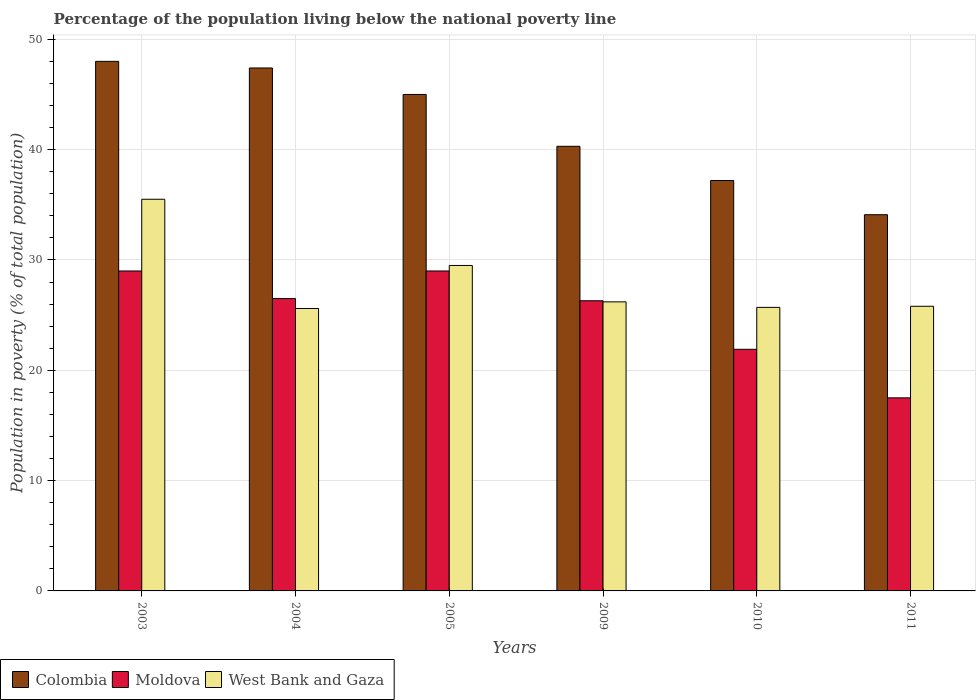How many different coloured bars are there?
Provide a succinct answer. 3. Are the number of bars on each tick of the X-axis equal?
Make the answer very short. Yes. How many bars are there on the 1st tick from the left?
Give a very brief answer. 3. How many bars are there on the 3rd tick from the right?
Provide a succinct answer. 3. What is the label of the 3rd group of bars from the left?
Offer a very short reply. 2005. Across all years, what is the maximum percentage of the population living below the national poverty line in Colombia?
Provide a short and direct response. 48. Across all years, what is the minimum percentage of the population living below the national poverty line in Colombia?
Offer a very short reply. 34.1. What is the total percentage of the population living below the national poverty line in West Bank and Gaza in the graph?
Your answer should be compact. 168.3. What is the difference between the percentage of the population living below the national poverty line in Colombia in 2010 and the percentage of the population living below the national poverty line in West Bank and Gaza in 2004?
Provide a succinct answer. 11.6. What is the average percentage of the population living below the national poverty line in Colombia per year?
Your response must be concise. 42. In the year 2004, what is the difference between the percentage of the population living below the national poverty line in Moldova and percentage of the population living below the national poverty line in West Bank and Gaza?
Your response must be concise. 0.9. What is the ratio of the percentage of the population living below the national poverty line in Moldova in 2005 to that in 2010?
Ensure brevity in your answer.  1.32. Is the percentage of the population living below the national poverty line in Colombia in 2010 less than that in 2011?
Provide a succinct answer. No. Is the difference between the percentage of the population living below the national poverty line in Moldova in 2003 and 2009 greater than the difference between the percentage of the population living below the national poverty line in West Bank and Gaza in 2003 and 2009?
Provide a short and direct response. No. What is the difference between the highest and the second highest percentage of the population living below the national poverty line in Moldova?
Your answer should be very brief. 0. In how many years, is the percentage of the population living below the national poverty line in Moldova greater than the average percentage of the population living below the national poverty line in Moldova taken over all years?
Give a very brief answer. 4. Is the sum of the percentage of the population living below the national poverty line in Colombia in 2004 and 2005 greater than the maximum percentage of the population living below the national poverty line in West Bank and Gaza across all years?
Give a very brief answer. Yes. What does the 2nd bar from the left in 2010 represents?
Your answer should be compact. Moldova. What does the 2nd bar from the right in 2010 represents?
Ensure brevity in your answer.  Moldova. Is it the case that in every year, the sum of the percentage of the population living below the national poverty line in Moldova and percentage of the population living below the national poverty line in West Bank and Gaza is greater than the percentage of the population living below the national poverty line in Colombia?
Ensure brevity in your answer.  Yes. How many bars are there?
Give a very brief answer. 18. Are all the bars in the graph horizontal?
Your response must be concise. No. How many years are there in the graph?
Your response must be concise. 6. Are the values on the major ticks of Y-axis written in scientific E-notation?
Make the answer very short. No. Does the graph contain grids?
Offer a very short reply. Yes. How many legend labels are there?
Offer a very short reply. 3. What is the title of the graph?
Provide a succinct answer. Percentage of the population living below the national poverty line. Does "Congo (Democratic)" appear as one of the legend labels in the graph?
Provide a short and direct response. No. What is the label or title of the X-axis?
Ensure brevity in your answer.  Years. What is the label or title of the Y-axis?
Offer a very short reply. Population in poverty (% of total population). What is the Population in poverty (% of total population) of Moldova in 2003?
Keep it short and to the point. 29. What is the Population in poverty (% of total population) in West Bank and Gaza in 2003?
Ensure brevity in your answer.  35.5. What is the Population in poverty (% of total population) of Colombia in 2004?
Your answer should be very brief. 47.4. What is the Population in poverty (% of total population) of West Bank and Gaza in 2004?
Provide a succinct answer. 25.6. What is the Population in poverty (% of total population) in Moldova in 2005?
Your answer should be very brief. 29. What is the Population in poverty (% of total population) in West Bank and Gaza in 2005?
Provide a succinct answer. 29.5. What is the Population in poverty (% of total population) in Colombia in 2009?
Make the answer very short. 40.3. What is the Population in poverty (% of total population) in Moldova in 2009?
Offer a terse response. 26.3. What is the Population in poverty (% of total population) of West Bank and Gaza in 2009?
Make the answer very short. 26.2. What is the Population in poverty (% of total population) of Colombia in 2010?
Make the answer very short. 37.2. What is the Population in poverty (% of total population) of Moldova in 2010?
Your answer should be compact. 21.9. What is the Population in poverty (% of total population) in West Bank and Gaza in 2010?
Provide a short and direct response. 25.7. What is the Population in poverty (% of total population) in Colombia in 2011?
Your answer should be very brief. 34.1. What is the Population in poverty (% of total population) in West Bank and Gaza in 2011?
Provide a short and direct response. 25.8. Across all years, what is the maximum Population in poverty (% of total population) in West Bank and Gaza?
Offer a very short reply. 35.5. Across all years, what is the minimum Population in poverty (% of total population) in Colombia?
Your answer should be compact. 34.1. Across all years, what is the minimum Population in poverty (% of total population) of West Bank and Gaza?
Make the answer very short. 25.6. What is the total Population in poverty (% of total population) of Colombia in the graph?
Offer a very short reply. 252. What is the total Population in poverty (% of total population) in Moldova in the graph?
Your answer should be compact. 150.2. What is the total Population in poverty (% of total population) of West Bank and Gaza in the graph?
Make the answer very short. 168.3. What is the difference between the Population in poverty (% of total population) in Moldova in 2003 and that in 2004?
Your answer should be very brief. 2.5. What is the difference between the Population in poverty (% of total population) of Colombia in 2003 and that in 2005?
Offer a terse response. 3. What is the difference between the Population in poverty (% of total population) in West Bank and Gaza in 2003 and that in 2005?
Ensure brevity in your answer.  6. What is the difference between the Population in poverty (% of total population) of Colombia in 2003 and that in 2009?
Keep it short and to the point. 7.7. What is the difference between the Population in poverty (% of total population) in Moldova in 2003 and that in 2009?
Provide a succinct answer. 2.7. What is the difference between the Population in poverty (% of total population) in Moldova in 2003 and that in 2010?
Ensure brevity in your answer.  7.1. What is the difference between the Population in poverty (% of total population) in West Bank and Gaza in 2003 and that in 2010?
Your answer should be compact. 9.8. What is the difference between the Population in poverty (% of total population) of Colombia in 2003 and that in 2011?
Your response must be concise. 13.9. What is the difference between the Population in poverty (% of total population) of Moldova in 2004 and that in 2005?
Keep it short and to the point. -2.5. What is the difference between the Population in poverty (% of total population) of West Bank and Gaza in 2004 and that in 2005?
Your response must be concise. -3.9. What is the difference between the Population in poverty (% of total population) in Moldova in 2004 and that in 2009?
Your response must be concise. 0.2. What is the difference between the Population in poverty (% of total population) of Colombia in 2004 and that in 2010?
Offer a terse response. 10.2. What is the difference between the Population in poverty (% of total population) of Moldova in 2004 and that in 2010?
Your response must be concise. 4.6. What is the difference between the Population in poverty (% of total population) of Colombia in 2005 and that in 2009?
Offer a very short reply. 4.7. What is the difference between the Population in poverty (% of total population) of Moldova in 2005 and that in 2009?
Your answer should be compact. 2.7. What is the difference between the Population in poverty (% of total population) in West Bank and Gaza in 2005 and that in 2009?
Your answer should be very brief. 3.3. What is the difference between the Population in poverty (% of total population) of Moldova in 2005 and that in 2011?
Offer a very short reply. 11.5. What is the difference between the Population in poverty (% of total population) in Moldova in 2009 and that in 2010?
Your response must be concise. 4.4. What is the difference between the Population in poverty (% of total population) of West Bank and Gaza in 2009 and that in 2010?
Your answer should be compact. 0.5. What is the difference between the Population in poverty (% of total population) in West Bank and Gaza in 2010 and that in 2011?
Your response must be concise. -0.1. What is the difference between the Population in poverty (% of total population) in Colombia in 2003 and the Population in poverty (% of total population) in Moldova in 2004?
Provide a short and direct response. 21.5. What is the difference between the Population in poverty (% of total population) in Colombia in 2003 and the Population in poverty (% of total population) in West Bank and Gaza in 2004?
Provide a succinct answer. 22.4. What is the difference between the Population in poverty (% of total population) of Colombia in 2003 and the Population in poverty (% of total population) of Moldova in 2009?
Offer a very short reply. 21.7. What is the difference between the Population in poverty (% of total population) of Colombia in 2003 and the Population in poverty (% of total population) of West Bank and Gaza in 2009?
Offer a very short reply. 21.8. What is the difference between the Population in poverty (% of total population) of Moldova in 2003 and the Population in poverty (% of total population) of West Bank and Gaza in 2009?
Offer a very short reply. 2.8. What is the difference between the Population in poverty (% of total population) of Colombia in 2003 and the Population in poverty (% of total population) of Moldova in 2010?
Provide a short and direct response. 26.1. What is the difference between the Population in poverty (% of total population) of Colombia in 2003 and the Population in poverty (% of total population) of West Bank and Gaza in 2010?
Your response must be concise. 22.3. What is the difference between the Population in poverty (% of total population) of Colombia in 2003 and the Population in poverty (% of total population) of Moldova in 2011?
Your response must be concise. 30.5. What is the difference between the Population in poverty (% of total population) of Colombia in 2004 and the Population in poverty (% of total population) of West Bank and Gaza in 2005?
Give a very brief answer. 17.9. What is the difference between the Population in poverty (% of total population) in Moldova in 2004 and the Population in poverty (% of total population) in West Bank and Gaza in 2005?
Offer a very short reply. -3. What is the difference between the Population in poverty (% of total population) of Colombia in 2004 and the Population in poverty (% of total population) of Moldova in 2009?
Give a very brief answer. 21.1. What is the difference between the Population in poverty (% of total population) in Colombia in 2004 and the Population in poverty (% of total population) in West Bank and Gaza in 2009?
Make the answer very short. 21.2. What is the difference between the Population in poverty (% of total population) in Moldova in 2004 and the Population in poverty (% of total population) in West Bank and Gaza in 2009?
Ensure brevity in your answer.  0.3. What is the difference between the Population in poverty (% of total population) of Colombia in 2004 and the Population in poverty (% of total population) of West Bank and Gaza in 2010?
Give a very brief answer. 21.7. What is the difference between the Population in poverty (% of total population) in Moldova in 2004 and the Population in poverty (% of total population) in West Bank and Gaza in 2010?
Make the answer very short. 0.8. What is the difference between the Population in poverty (% of total population) of Colombia in 2004 and the Population in poverty (% of total population) of Moldova in 2011?
Your answer should be very brief. 29.9. What is the difference between the Population in poverty (% of total population) of Colombia in 2004 and the Population in poverty (% of total population) of West Bank and Gaza in 2011?
Offer a very short reply. 21.6. What is the difference between the Population in poverty (% of total population) of Colombia in 2005 and the Population in poverty (% of total population) of West Bank and Gaza in 2009?
Your answer should be compact. 18.8. What is the difference between the Population in poverty (% of total population) of Moldova in 2005 and the Population in poverty (% of total population) of West Bank and Gaza in 2009?
Provide a succinct answer. 2.8. What is the difference between the Population in poverty (% of total population) in Colombia in 2005 and the Population in poverty (% of total population) in Moldova in 2010?
Provide a short and direct response. 23.1. What is the difference between the Population in poverty (% of total population) in Colombia in 2005 and the Population in poverty (% of total population) in West Bank and Gaza in 2010?
Your answer should be very brief. 19.3. What is the difference between the Population in poverty (% of total population) in Moldova in 2005 and the Population in poverty (% of total population) in West Bank and Gaza in 2010?
Keep it short and to the point. 3.3. What is the difference between the Population in poverty (% of total population) of Colombia in 2005 and the Population in poverty (% of total population) of Moldova in 2011?
Offer a very short reply. 27.5. What is the difference between the Population in poverty (% of total population) of Colombia in 2009 and the Population in poverty (% of total population) of Moldova in 2011?
Keep it short and to the point. 22.8. What is the difference between the Population in poverty (% of total population) of Colombia in 2009 and the Population in poverty (% of total population) of West Bank and Gaza in 2011?
Keep it short and to the point. 14.5. What is the difference between the Population in poverty (% of total population) of Colombia in 2010 and the Population in poverty (% of total population) of Moldova in 2011?
Ensure brevity in your answer.  19.7. What is the difference between the Population in poverty (% of total population) in Moldova in 2010 and the Population in poverty (% of total population) in West Bank and Gaza in 2011?
Your answer should be compact. -3.9. What is the average Population in poverty (% of total population) in Colombia per year?
Make the answer very short. 42. What is the average Population in poverty (% of total population) of Moldova per year?
Offer a very short reply. 25.03. What is the average Population in poverty (% of total population) in West Bank and Gaza per year?
Offer a terse response. 28.05. In the year 2003, what is the difference between the Population in poverty (% of total population) in Colombia and Population in poverty (% of total population) in Moldova?
Offer a terse response. 19. In the year 2004, what is the difference between the Population in poverty (% of total population) in Colombia and Population in poverty (% of total population) in Moldova?
Offer a terse response. 20.9. In the year 2004, what is the difference between the Population in poverty (% of total population) in Colombia and Population in poverty (% of total population) in West Bank and Gaza?
Make the answer very short. 21.8. In the year 2005, what is the difference between the Population in poverty (% of total population) in Colombia and Population in poverty (% of total population) in West Bank and Gaza?
Make the answer very short. 15.5. In the year 2005, what is the difference between the Population in poverty (% of total population) of Moldova and Population in poverty (% of total population) of West Bank and Gaza?
Ensure brevity in your answer.  -0.5. In the year 2010, what is the difference between the Population in poverty (% of total population) in Colombia and Population in poverty (% of total population) in Moldova?
Provide a short and direct response. 15.3. In the year 2010, what is the difference between the Population in poverty (% of total population) in Colombia and Population in poverty (% of total population) in West Bank and Gaza?
Ensure brevity in your answer.  11.5. In the year 2011, what is the difference between the Population in poverty (% of total population) of Colombia and Population in poverty (% of total population) of Moldova?
Provide a succinct answer. 16.6. What is the ratio of the Population in poverty (% of total population) in Colombia in 2003 to that in 2004?
Keep it short and to the point. 1.01. What is the ratio of the Population in poverty (% of total population) of Moldova in 2003 to that in 2004?
Make the answer very short. 1.09. What is the ratio of the Population in poverty (% of total population) of West Bank and Gaza in 2003 to that in 2004?
Offer a terse response. 1.39. What is the ratio of the Population in poverty (% of total population) in Colombia in 2003 to that in 2005?
Your answer should be compact. 1.07. What is the ratio of the Population in poverty (% of total population) of Moldova in 2003 to that in 2005?
Your answer should be compact. 1. What is the ratio of the Population in poverty (% of total population) of West Bank and Gaza in 2003 to that in 2005?
Offer a terse response. 1.2. What is the ratio of the Population in poverty (% of total population) of Colombia in 2003 to that in 2009?
Give a very brief answer. 1.19. What is the ratio of the Population in poverty (% of total population) of Moldova in 2003 to that in 2009?
Provide a succinct answer. 1.1. What is the ratio of the Population in poverty (% of total population) in West Bank and Gaza in 2003 to that in 2009?
Provide a succinct answer. 1.35. What is the ratio of the Population in poverty (% of total population) in Colombia in 2003 to that in 2010?
Keep it short and to the point. 1.29. What is the ratio of the Population in poverty (% of total population) of Moldova in 2003 to that in 2010?
Offer a terse response. 1.32. What is the ratio of the Population in poverty (% of total population) in West Bank and Gaza in 2003 to that in 2010?
Provide a short and direct response. 1.38. What is the ratio of the Population in poverty (% of total population) of Colombia in 2003 to that in 2011?
Offer a terse response. 1.41. What is the ratio of the Population in poverty (% of total population) in Moldova in 2003 to that in 2011?
Your response must be concise. 1.66. What is the ratio of the Population in poverty (% of total population) in West Bank and Gaza in 2003 to that in 2011?
Keep it short and to the point. 1.38. What is the ratio of the Population in poverty (% of total population) of Colombia in 2004 to that in 2005?
Offer a terse response. 1.05. What is the ratio of the Population in poverty (% of total population) of Moldova in 2004 to that in 2005?
Give a very brief answer. 0.91. What is the ratio of the Population in poverty (% of total population) in West Bank and Gaza in 2004 to that in 2005?
Ensure brevity in your answer.  0.87. What is the ratio of the Population in poverty (% of total population) in Colombia in 2004 to that in 2009?
Ensure brevity in your answer.  1.18. What is the ratio of the Population in poverty (% of total population) of Moldova in 2004 to that in 2009?
Your response must be concise. 1.01. What is the ratio of the Population in poverty (% of total population) in West Bank and Gaza in 2004 to that in 2009?
Give a very brief answer. 0.98. What is the ratio of the Population in poverty (% of total population) in Colombia in 2004 to that in 2010?
Ensure brevity in your answer.  1.27. What is the ratio of the Population in poverty (% of total population) of Moldova in 2004 to that in 2010?
Ensure brevity in your answer.  1.21. What is the ratio of the Population in poverty (% of total population) of Colombia in 2004 to that in 2011?
Provide a succinct answer. 1.39. What is the ratio of the Population in poverty (% of total population) in Moldova in 2004 to that in 2011?
Your response must be concise. 1.51. What is the ratio of the Population in poverty (% of total population) in Colombia in 2005 to that in 2009?
Offer a terse response. 1.12. What is the ratio of the Population in poverty (% of total population) in Moldova in 2005 to that in 2009?
Your response must be concise. 1.1. What is the ratio of the Population in poverty (% of total population) in West Bank and Gaza in 2005 to that in 2009?
Your answer should be compact. 1.13. What is the ratio of the Population in poverty (% of total population) of Colombia in 2005 to that in 2010?
Make the answer very short. 1.21. What is the ratio of the Population in poverty (% of total population) in Moldova in 2005 to that in 2010?
Ensure brevity in your answer.  1.32. What is the ratio of the Population in poverty (% of total population) of West Bank and Gaza in 2005 to that in 2010?
Keep it short and to the point. 1.15. What is the ratio of the Population in poverty (% of total population) of Colombia in 2005 to that in 2011?
Ensure brevity in your answer.  1.32. What is the ratio of the Population in poverty (% of total population) of Moldova in 2005 to that in 2011?
Your response must be concise. 1.66. What is the ratio of the Population in poverty (% of total population) in West Bank and Gaza in 2005 to that in 2011?
Provide a short and direct response. 1.14. What is the ratio of the Population in poverty (% of total population) of Colombia in 2009 to that in 2010?
Your answer should be very brief. 1.08. What is the ratio of the Population in poverty (% of total population) of Moldova in 2009 to that in 2010?
Offer a very short reply. 1.2. What is the ratio of the Population in poverty (% of total population) in West Bank and Gaza in 2009 to that in 2010?
Your answer should be compact. 1.02. What is the ratio of the Population in poverty (% of total population) of Colombia in 2009 to that in 2011?
Provide a short and direct response. 1.18. What is the ratio of the Population in poverty (% of total population) of Moldova in 2009 to that in 2011?
Keep it short and to the point. 1.5. What is the ratio of the Population in poverty (% of total population) of West Bank and Gaza in 2009 to that in 2011?
Ensure brevity in your answer.  1.02. What is the ratio of the Population in poverty (% of total population) in Colombia in 2010 to that in 2011?
Make the answer very short. 1.09. What is the ratio of the Population in poverty (% of total population) in Moldova in 2010 to that in 2011?
Offer a terse response. 1.25. What is the difference between the highest and the second highest Population in poverty (% of total population) of Colombia?
Make the answer very short. 0.6. What is the difference between the highest and the second highest Population in poverty (% of total population) of Moldova?
Keep it short and to the point. 0. What is the difference between the highest and the lowest Population in poverty (% of total population) in Colombia?
Provide a succinct answer. 13.9. 